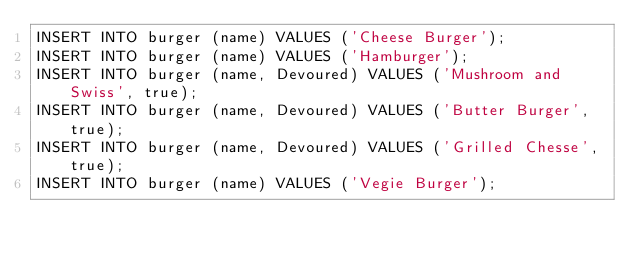Convert code to text. <code><loc_0><loc_0><loc_500><loc_500><_SQL_>INSERT INTO burger (name) VALUES ('Cheese Burger');
INSERT INTO burger (name) VALUES ('Hamburger');
INSERT INTO burger (name, Devoured) VALUES ('Mushroom and Swiss', true);
INSERT INTO burger (name, Devoured) VALUES ('Butter Burger', true);
INSERT INTO burger (name, Devoured) VALUES ('Grilled Chesse', true);
INSERT INTO burger (name) VALUES ('Vegie Burger');
</code> 